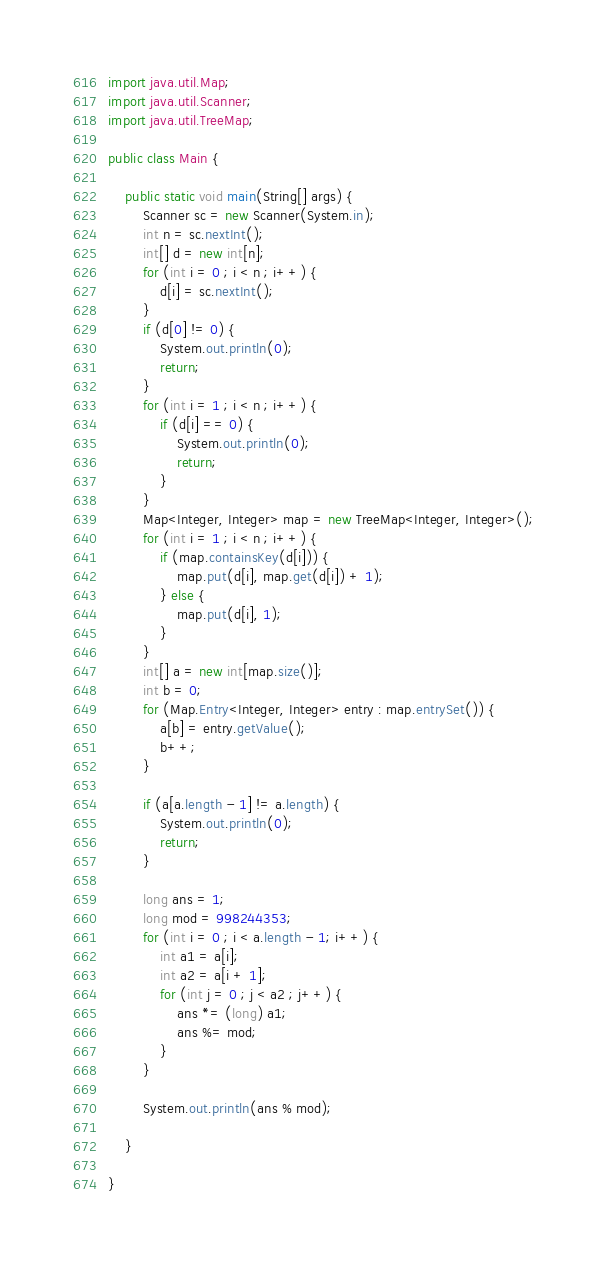<code> <loc_0><loc_0><loc_500><loc_500><_Java_>import java.util.Map;
import java.util.Scanner;
import java.util.TreeMap;

public class Main {

    public static void main(String[] args) {
        Scanner sc = new Scanner(System.in);
        int n = sc.nextInt();
        int[] d = new int[n];
        for (int i = 0 ; i < n ; i++) {
            d[i] = sc.nextInt();
        }
        if (d[0] != 0) {
            System.out.println(0);
            return;
        }
        for (int i = 1 ; i < n ; i++) {
            if (d[i] == 0) {
                System.out.println(0);
                return;
            }
        }
        Map<Integer, Integer> map = new TreeMap<Integer, Integer>();
        for (int i = 1 ; i < n ; i++) {
            if (map.containsKey(d[i])) {
                map.put(d[i], map.get(d[i]) + 1);
            } else {
                map.put(d[i], 1);
            }
        }
        int[] a = new int[map.size()];
        int b = 0;
        for (Map.Entry<Integer, Integer> entry : map.entrySet()) {
            a[b] = entry.getValue();
            b++;
        }

        if (a[a.length - 1] != a.length) {
            System.out.println(0);
            return;
        }

        long ans = 1;
        long mod = 998244353;
        for (int i = 0 ; i < a.length - 1; i++) {
            int a1 = a[i];
            int a2 = a[i + 1];
            for (int j = 0 ; j < a2 ; j++) {
                ans *= (long) a1;
                ans %= mod;
            }
        }

        System.out.println(ans % mod);

    }

}</code> 